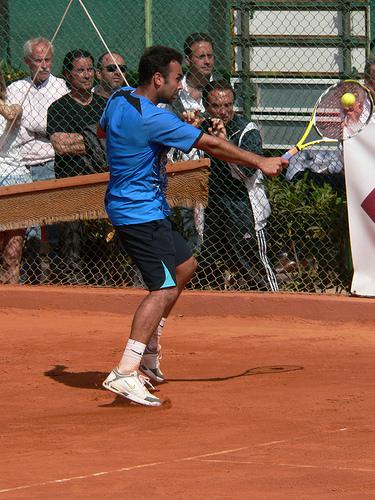Question: how many players are shown?
Choices:
A. 2.
B. 3.
C. 4.
D. 1.
Answer with the letter. Answer: D Question: what sport is shown?
Choices:
A. Baseball.
B. Football.
C. Soccer.
D. Tennis.
Answer with the letter. Answer: D Question: where is this shot?
Choices:
A. Baseball diamond.
B. Football field.
C. Soccer field.
D. Tennis quart.
Answer with the letter. Answer: D Question: what color is the court?
Choices:
A. Brown.
B. Blue.
C. Green.
D. Yellow.
Answer with the letter. Answer: A Question: what is the player hitting?
Choices:
A. Baseball.
B. Volleyball.
C. Handball.
D. Tennis ball.
Answer with the letter. Answer: D Question: what type of swing is this called?
Choices:
A. Forehand.
B. Backhand.
C. Linedrive.
D. Tire.
Answer with the letter. Answer: B 